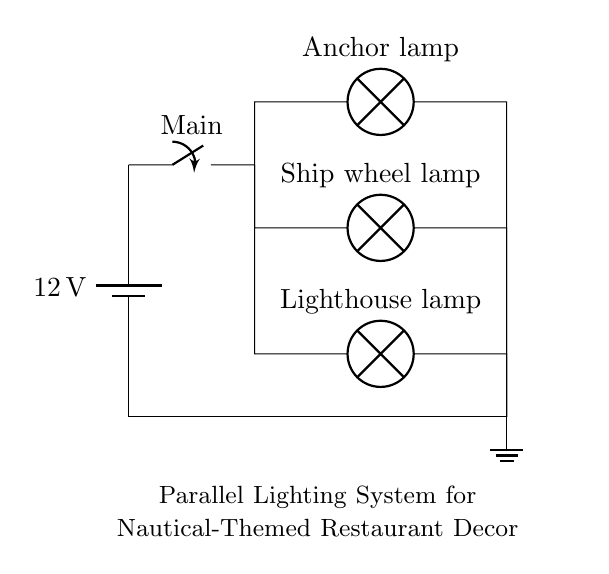What is the voltage of the circuit? The voltage is 12V, indicated by the battery symbol at the left side of the diagram labeled with a value of 12.
Answer: 12V What type of lighting system is shown in the diagram? The diagram illustrates a parallel lighting system, as indicated by the multiple branches connected to the main power source.
Answer: Parallel How many lamps are connected in parallel? There are three lamps connected in parallel, as seen in the three branches leading from the main switch.
Answer: Three What is the role of the main switch in this circuit? The main switch controls the flow of electricity to all connected lamps, allowing them to be turned on or off simultaneously.
Answer: Control If one lamp fails, what happens to the other lamps? The other lamps will stay lit because a parallel circuit allows for individual branches to function independently of one another.
Answer: Stay lit What type of lamps are used in the circuit? The lamps are labeled as Anchor lamp, Ship wheel lamp, and Lighthouse lamp, which reflect the nautical theme of the restaurant's decor.
Answer: Nautical-themed lamps 